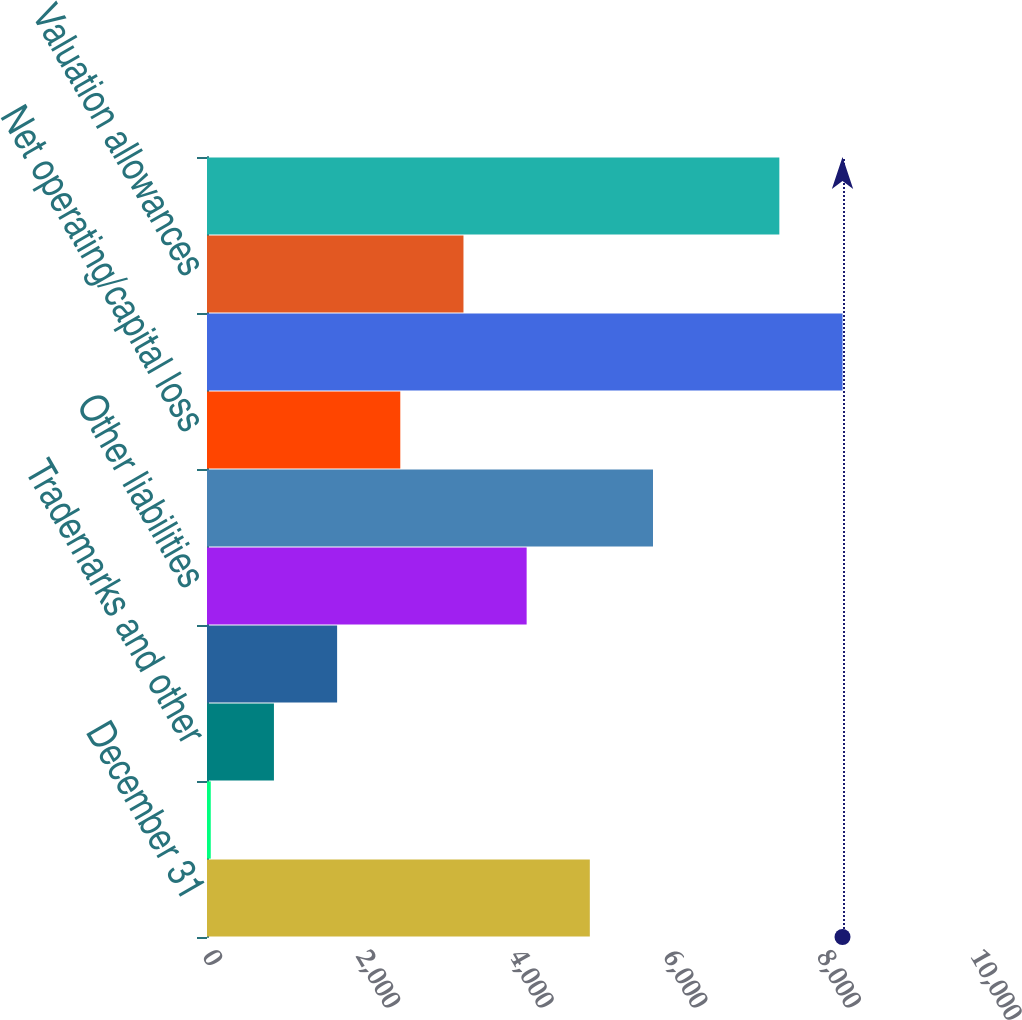Convert chart. <chart><loc_0><loc_0><loc_500><loc_500><bar_chart><fcel>December 31<fcel>Property plant and equipment<fcel>Trademarks and other<fcel>Equity method investments<fcel>Other liabilities<fcel>Benefit plans<fcel>Net operating/capital loss<fcel>Gross deferred tax assets<fcel>Valuation allowances<fcel>Total deferred tax assets 23<nl><fcel>4984.6<fcel>49<fcel>871.6<fcel>1694.2<fcel>4162<fcel>5807.2<fcel>2516.8<fcel>8275<fcel>3339.4<fcel>7452.4<nl></chart> 